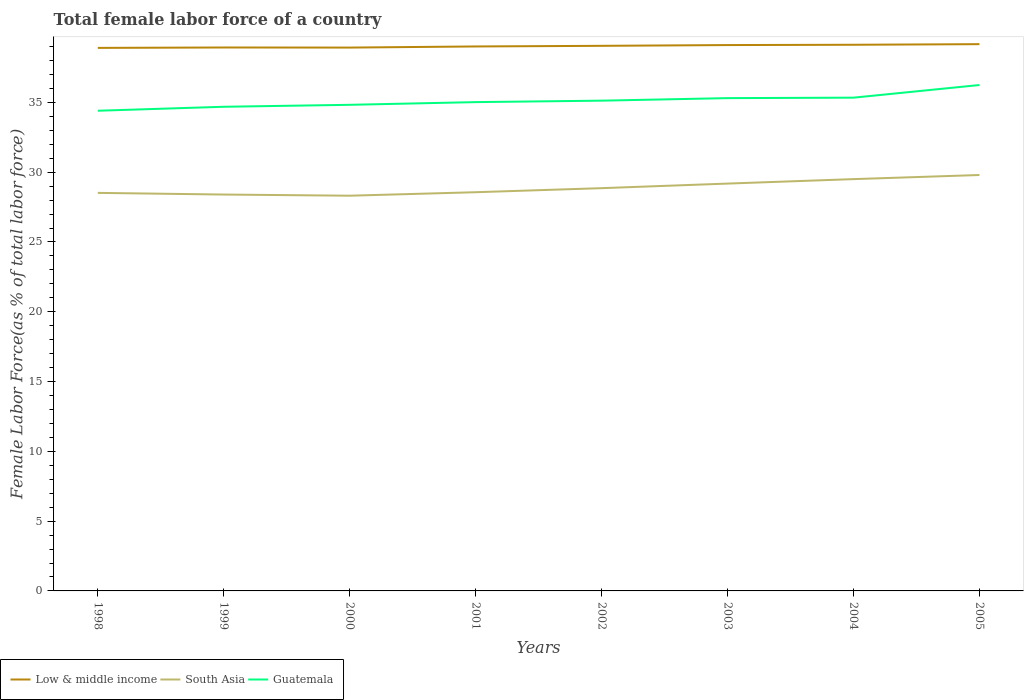How many different coloured lines are there?
Keep it short and to the point. 3. Does the line corresponding to South Asia intersect with the line corresponding to Guatemala?
Offer a very short reply. No. Across all years, what is the maximum percentage of female labor force in Guatemala?
Offer a terse response. 34.4. What is the total percentage of female labor force in South Asia in the graph?
Keep it short and to the point. -0.25. What is the difference between the highest and the second highest percentage of female labor force in Low & middle income?
Your answer should be very brief. 0.27. How many years are there in the graph?
Ensure brevity in your answer.  8. What is the difference between two consecutive major ticks on the Y-axis?
Your response must be concise. 5. How are the legend labels stacked?
Your answer should be very brief. Horizontal. What is the title of the graph?
Provide a succinct answer. Total female labor force of a country. What is the label or title of the Y-axis?
Your answer should be very brief. Female Labor Force(as % of total labor force). What is the Female Labor Force(as % of total labor force) in Low & middle income in 1998?
Give a very brief answer. 38.91. What is the Female Labor Force(as % of total labor force) in South Asia in 1998?
Provide a short and direct response. 28.52. What is the Female Labor Force(as % of total labor force) of Guatemala in 1998?
Your answer should be very brief. 34.4. What is the Female Labor Force(as % of total labor force) in Low & middle income in 1999?
Ensure brevity in your answer.  38.93. What is the Female Labor Force(as % of total labor force) in South Asia in 1999?
Offer a very short reply. 28.4. What is the Female Labor Force(as % of total labor force) in Guatemala in 1999?
Your response must be concise. 34.69. What is the Female Labor Force(as % of total labor force) in Low & middle income in 2000?
Make the answer very short. 38.93. What is the Female Labor Force(as % of total labor force) in South Asia in 2000?
Offer a terse response. 28.32. What is the Female Labor Force(as % of total labor force) of Guatemala in 2000?
Ensure brevity in your answer.  34.83. What is the Female Labor Force(as % of total labor force) of Low & middle income in 2001?
Give a very brief answer. 39.01. What is the Female Labor Force(as % of total labor force) of South Asia in 2001?
Ensure brevity in your answer.  28.57. What is the Female Labor Force(as % of total labor force) in Guatemala in 2001?
Your answer should be very brief. 35.02. What is the Female Labor Force(as % of total labor force) in Low & middle income in 2002?
Give a very brief answer. 39.05. What is the Female Labor Force(as % of total labor force) of South Asia in 2002?
Give a very brief answer. 28.86. What is the Female Labor Force(as % of total labor force) in Guatemala in 2002?
Your answer should be compact. 35.13. What is the Female Labor Force(as % of total labor force) of Low & middle income in 2003?
Your answer should be very brief. 39.11. What is the Female Labor Force(as % of total labor force) of South Asia in 2003?
Give a very brief answer. 29.18. What is the Female Labor Force(as % of total labor force) in Guatemala in 2003?
Provide a short and direct response. 35.31. What is the Female Labor Force(as % of total labor force) of Low & middle income in 2004?
Your response must be concise. 39.13. What is the Female Labor Force(as % of total labor force) of South Asia in 2004?
Provide a short and direct response. 29.5. What is the Female Labor Force(as % of total labor force) in Guatemala in 2004?
Ensure brevity in your answer.  35.34. What is the Female Labor Force(as % of total labor force) of Low & middle income in 2005?
Your answer should be compact. 39.17. What is the Female Labor Force(as % of total labor force) in South Asia in 2005?
Offer a very short reply. 29.8. What is the Female Labor Force(as % of total labor force) of Guatemala in 2005?
Make the answer very short. 36.25. Across all years, what is the maximum Female Labor Force(as % of total labor force) in Low & middle income?
Make the answer very short. 39.17. Across all years, what is the maximum Female Labor Force(as % of total labor force) in South Asia?
Your answer should be compact. 29.8. Across all years, what is the maximum Female Labor Force(as % of total labor force) in Guatemala?
Ensure brevity in your answer.  36.25. Across all years, what is the minimum Female Labor Force(as % of total labor force) in Low & middle income?
Offer a very short reply. 38.91. Across all years, what is the minimum Female Labor Force(as % of total labor force) in South Asia?
Your answer should be compact. 28.32. Across all years, what is the minimum Female Labor Force(as % of total labor force) of Guatemala?
Provide a short and direct response. 34.4. What is the total Female Labor Force(as % of total labor force) of Low & middle income in the graph?
Provide a short and direct response. 312.25. What is the total Female Labor Force(as % of total labor force) of South Asia in the graph?
Provide a short and direct response. 231.14. What is the total Female Labor Force(as % of total labor force) in Guatemala in the graph?
Your answer should be compact. 280.96. What is the difference between the Female Labor Force(as % of total labor force) of Low & middle income in 1998 and that in 1999?
Your answer should be very brief. -0.03. What is the difference between the Female Labor Force(as % of total labor force) in South Asia in 1998 and that in 1999?
Offer a very short reply. 0.12. What is the difference between the Female Labor Force(as % of total labor force) of Guatemala in 1998 and that in 1999?
Offer a very short reply. -0.28. What is the difference between the Female Labor Force(as % of total labor force) in Low & middle income in 1998 and that in 2000?
Make the answer very short. -0.02. What is the difference between the Female Labor Force(as % of total labor force) in South Asia in 1998 and that in 2000?
Provide a succinct answer. 0.2. What is the difference between the Female Labor Force(as % of total labor force) in Guatemala in 1998 and that in 2000?
Provide a short and direct response. -0.42. What is the difference between the Female Labor Force(as % of total labor force) in Low & middle income in 1998 and that in 2001?
Your response must be concise. -0.1. What is the difference between the Female Labor Force(as % of total labor force) in South Asia in 1998 and that in 2001?
Ensure brevity in your answer.  -0.05. What is the difference between the Female Labor Force(as % of total labor force) in Guatemala in 1998 and that in 2001?
Your response must be concise. -0.62. What is the difference between the Female Labor Force(as % of total labor force) in Low & middle income in 1998 and that in 2002?
Offer a very short reply. -0.15. What is the difference between the Female Labor Force(as % of total labor force) of South Asia in 1998 and that in 2002?
Offer a very short reply. -0.34. What is the difference between the Female Labor Force(as % of total labor force) in Guatemala in 1998 and that in 2002?
Your response must be concise. -0.72. What is the difference between the Female Labor Force(as % of total labor force) in Low & middle income in 1998 and that in 2003?
Your response must be concise. -0.2. What is the difference between the Female Labor Force(as % of total labor force) in South Asia in 1998 and that in 2003?
Your answer should be very brief. -0.67. What is the difference between the Female Labor Force(as % of total labor force) in Guatemala in 1998 and that in 2003?
Offer a terse response. -0.9. What is the difference between the Female Labor Force(as % of total labor force) in Low & middle income in 1998 and that in 2004?
Your answer should be very brief. -0.22. What is the difference between the Female Labor Force(as % of total labor force) of South Asia in 1998 and that in 2004?
Your answer should be very brief. -0.98. What is the difference between the Female Labor Force(as % of total labor force) of Guatemala in 1998 and that in 2004?
Make the answer very short. -0.94. What is the difference between the Female Labor Force(as % of total labor force) in Low & middle income in 1998 and that in 2005?
Offer a terse response. -0.27. What is the difference between the Female Labor Force(as % of total labor force) in South Asia in 1998 and that in 2005?
Offer a very short reply. -1.28. What is the difference between the Female Labor Force(as % of total labor force) in Guatemala in 1998 and that in 2005?
Offer a very short reply. -1.84. What is the difference between the Female Labor Force(as % of total labor force) in Low & middle income in 1999 and that in 2000?
Offer a terse response. 0.01. What is the difference between the Female Labor Force(as % of total labor force) in South Asia in 1999 and that in 2000?
Ensure brevity in your answer.  0.08. What is the difference between the Female Labor Force(as % of total labor force) of Guatemala in 1999 and that in 2000?
Ensure brevity in your answer.  -0.14. What is the difference between the Female Labor Force(as % of total labor force) of Low & middle income in 1999 and that in 2001?
Give a very brief answer. -0.07. What is the difference between the Female Labor Force(as % of total labor force) in South Asia in 1999 and that in 2001?
Offer a very short reply. -0.17. What is the difference between the Female Labor Force(as % of total labor force) of Guatemala in 1999 and that in 2001?
Your answer should be very brief. -0.33. What is the difference between the Female Labor Force(as % of total labor force) in Low & middle income in 1999 and that in 2002?
Provide a short and direct response. -0.12. What is the difference between the Female Labor Force(as % of total labor force) in South Asia in 1999 and that in 2002?
Offer a very short reply. -0.46. What is the difference between the Female Labor Force(as % of total labor force) of Guatemala in 1999 and that in 2002?
Give a very brief answer. -0.44. What is the difference between the Female Labor Force(as % of total labor force) of Low & middle income in 1999 and that in 2003?
Your answer should be very brief. -0.17. What is the difference between the Female Labor Force(as % of total labor force) in South Asia in 1999 and that in 2003?
Provide a short and direct response. -0.79. What is the difference between the Female Labor Force(as % of total labor force) of Guatemala in 1999 and that in 2003?
Give a very brief answer. -0.62. What is the difference between the Female Labor Force(as % of total labor force) of Low & middle income in 1999 and that in 2004?
Your answer should be compact. -0.2. What is the difference between the Female Labor Force(as % of total labor force) of South Asia in 1999 and that in 2004?
Ensure brevity in your answer.  -1.1. What is the difference between the Female Labor Force(as % of total labor force) in Guatemala in 1999 and that in 2004?
Provide a short and direct response. -0.65. What is the difference between the Female Labor Force(as % of total labor force) of Low & middle income in 1999 and that in 2005?
Give a very brief answer. -0.24. What is the difference between the Female Labor Force(as % of total labor force) in South Asia in 1999 and that in 2005?
Offer a very short reply. -1.4. What is the difference between the Female Labor Force(as % of total labor force) in Guatemala in 1999 and that in 2005?
Provide a short and direct response. -1.56. What is the difference between the Female Labor Force(as % of total labor force) of Low & middle income in 2000 and that in 2001?
Provide a succinct answer. -0.08. What is the difference between the Female Labor Force(as % of total labor force) of South Asia in 2000 and that in 2001?
Your answer should be very brief. -0.25. What is the difference between the Female Labor Force(as % of total labor force) in Guatemala in 2000 and that in 2001?
Your response must be concise. -0.19. What is the difference between the Female Labor Force(as % of total labor force) in Low & middle income in 2000 and that in 2002?
Offer a terse response. -0.13. What is the difference between the Female Labor Force(as % of total labor force) in South Asia in 2000 and that in 2002?
Your response must be concise. -0.54. What is the difference between the Female Labor Force(as % of total labor force) in Guatemala in 2000 and that in 2002?
Your answer should be compact. -0.3. What is the difference between the Female Labor Force(as % of total labor force) in Low & middle income in 2000 and that in 2003?
Provide a succinct answer. -0.18. What is the difference between the Female Labor Force(as % of total labor force) in South Asia in 2000 and that in 2003?
Your answer should be very brief. -0.87. What is the difference between the Female Labor Force(as % of total labor force) of Guatemala in 2000 and that in 2003?
Provide a short and direct response. -0.48. What is the difference between the Female Labor Force(as % of total labor force) in Low & middle income in 2000 and that in 2004?
Your answer should be compact. -0.2. What is the difference between the Female Labor Force(as % of total labor force) of South Asia in 2000 and that in 2004?
Your answer should be compact. -1.19. What is the difference between the Female Labor Force(as % of total labor force) of Guatemala in 2000 and that in 2004?
Offer a terse response. -0.51. What is the difference between the Female Labor Force(as % of total labor force) in Low & middle income in 2000 and that in 2005?
Make the answer very short. -0.25. What is the difference between the Female Labor Force(as % of total labor force) in South Asia in 2000 and that in 2005?
Provide a short and direct response. -1.48. What is the difference between the Female Labor Force(as % of total labor force) of Guatemala in 2000 and that in 2005?
Provide a short and direct response. -1.42. What is the difference between the Female Labor Force(as % of total labor force) of Low & middle income in 2001 and that in 2002?
Provide a succinct answer. -0.04. What is the difference between the Female Labor Force(as % of total labor force) in South Asia in 2001 and that in 2002?
Your response must be concise. -0.29. What is the difference between the Female Labor Force(as % of total labor force) in Guatemala in 2001 and that in 2002?
Offer a terse response. -0.1. What is the difference between the Female Labor Force(as % of total labor force) of Low & middle income in 2001 and that in 2003?
Give a very brief answer. -0.1. What is the difference between the Female Labor Force(as % of total labor force) of South Asia in 2001 and that in 2003?
Ensure brevity in your answer.  -0.62. What is the difference between the Female Labor Force(as % of total labor force) of Guatemala in 2001 and that in 2003?
Your answer should be compact. -0.29. What is the difference between the Female Labor Force(as % of total labor force) of Low & middle income in 2001 and that in 2004?
Your answer should be very brief. -0.12. What is the difference between the Female Labor Force(as % of total labor force) in South Asia in 2001 and that in 2004?
Make the answer very short. -0.94. What is the difference between the Female Labor Force(as % of total labor force) of Guatemala in 2001 and that in 2004?
Your response must be concise. -0.32. What is the difference between the Female Labor Force(as % of total labor force) in Low & middle income in 2001 and that in 2005?
Your response must be concise. -0.16. What is the difference between the Female Labor Force(as % of total labor force) of South Asia in 2001 and that in 2005?
Ensure brevity in your answer.  -1.23. What is the difference between the Female Labor Force(as % of total labor force) in Guatemala in 2001 and that in 2005?
Provide a short and direct response. -1.23. What is the difference between the Female Labor Force(as % of total labor force) of Low & middle income in 2002 and that in 2003?
Make the answer very short. -0.05. What is the difference between the Female Labor Force(as % of total labor force) of South Asia in 2002 and that in 2003?
Your response must be concise. -0.33. What is the difference between the Female Labor Force(as % of total labor force) of Guatemala in 2002 and that in 2003?
Offer a very short reply. -0.18. What is the difference between the Female Labor Force(as % of total labor force) in Low & middle income in 2002 and that in 2004?
Provide a succinct answer. -0.08. What is the difference between the Female Labor Force(as % of total labor force) of South Asia in 2002 and that in 2004?
Provide a short and direct response. -0.65. What is the difference between the Female Labor Force(as % of total labor force) in Guatemala in 2002 and that in 2004?
Ensure brevity in your answer.  -0.21. What is the difference between the Female Labor Force(as % of total labor force) in Low & middle income in 2002 and that in 2005?
Provide a succinct answer. -0.12. What is the difference between the Female Labor Force(as % of total labor force) in South Asia in 2002 and that in 2005?
Your answer should be compact. -0.94. What is the difference between the Female Labor Force(as % of total labor force) of Guatemala in 2002 and that in 2005?
Offer a terse response. -1.12. What is the difference between the Female Labor Force(as % of total labor force) of Low & middle income in 2003 and that in 2004?
Provide a succinct answer. -0.02. What is the difference between the Female Labor Force(as % of total labor force) in South Asia in 2003 and that in 2004?
Provide a succinct answer. -0.32. What is the difference between the Female Labor Force(as % of total labor force) of Guatemala in 2003 and that in 2004?
Your answer should be compact. -0.03. What is the difference between the Female Labor Force(as % of total labor force) in Low & middle income in 2003 and that in 2005?
Offer a terse response. -0.07. What is the difference between the Female Labor Force(as % of total labor force) of South Asia in 2003 and that in 2005?
Provide a short and direct response. -0.61. What is the difference between the Female Labor Force(as % of total labor force) of Guatemala in 2003 and that in 2005?
Your answer should be compact. -0.94. What is the difference between the Female Labor Force(as % of total labor force) of Low & middle income in 2004 and that in 2005?
Provide a short and direct response. -0.04. What is the difference between the Female Labor Force(as % of total labor force) in South Asia in 2004 and that in 2005?
Your response must be concise. -0.3. What is the difference between the Female Labor Force(as % of total labor force) in Guatemala in 2004 and that in 2005?
Your answer should be very brief. -0.91. What is the difference between the Female Labor Force(as % of total labor force) of Low & middle income in 1998 and the Female Labor Force(as % of total labor force) of South Asia in 1999?
Provide a short and direct response. 10.51. What is the difference between the Female Labor Force(as % of total labor force) of Low & middle income in 1998 and the Female Labor Force(as % of total labor force) of Guatemala in 1999?
Provide a short and direct response. 4.22. What is the difference between the Female Labor Force(as % of total labor force) of South Asia in 1998 and the Female Labor Force(as % of total labor force) of Guatemala in 1999?
Offer a very short reply. -6.17. What is the difference between the Female Labor Force(as % of total labor force) in Low & middle income in 1998 and the Female Labor Force(as % of total labor force) in South Asia in 2000?
Offer a very short reply. 10.59. What is the difference between the Female Labor Force(as % of total labor force) of Low & middle income in 1998 and the Female Labor Force(as % of total labor force) of Guatemala in 2000?
Provide a short and direct response. 4.08. What is the difference between the Female Labor Force(as % of total labor force) in South Asia in 1998 and the Female Labor Force(as % of total labor force) in Guatemala in 2000?
Provide a succinct answer. -6.31. What is the difference between the Female Labor Force(as % of total labor force) of Low & middle income in 1998 and the Female Labor Force(as % of total labor force) of South Asia in 2001?
Make the answer very short. 10.34. What is the difference between the Female Labor Force(as % of total labor force) of Low & middle income in 1998 and the Female Labor Force(as % of total labor force) of Guatemala in 2001?
Keep it short and to the point. 3.88. What is the difference between the Female Labor Force(as % of total labor force) in South Asia in 1998 and the Female Labor Force(as % of total labor force) in Guatemala in 2001?
Offer a terse response. -6.5. What is the difference between the Female Labor Force(as % of total labor force) of Low & middle income in 1998 and the Female Labor Force(as % of total labor force) of South Asia in 2002?
Offer a terse response. 10.05. What is the difference between the Female Labor Force(as % of total labor force) of Low & middle income in 1998 and the Female Labor Force(as % of total labor force) of Guatemala in 2002?
Provide a short and direct response. 3.78. What is the difference between the Female Labor Force(as % of total labor force) of South Asia in 1998 and the Female Labor Force(as % of total labor force) of Guatemala in 2002?
Provide a short and direct response. -6.61. What is the difference between the Female Labor Force(as % of total labor force) in Low & middle income in 1998 and the Female Labor Force(as % of total labor force) in South Asia in 2003?
Make the answer very short. 9.72. What is the difference between the Female Labor Force(as % of total labor force) in Low & middle income in 1998 and the Female Labor Force(as % of total labor force) in Guatemala in 2003?
Offer a terse response. 3.6. What is the difference between the Female Labor Force(as % of total labor force) of South Asia in 1998 and the Female Labor Force(as % of total labor force) of Guatemala in 2003?
Ensure brevity in your answer.  -6.79. What is the difference between the Female Labor Force(as % of total labor force) in Low & middle income in 1998 and the Female Labor Force(as % of total labor force) in South Asia in 2004?
Offer a terse response. 9.4. What is the difference between the Female Labor Force(as % of total labor force) in Low & middle income in 1998 and the Female Labor Force(as % of total labor force) in Guatemala in 2004?
Your answer should be very brief. 3.57. What is the difference between the Female Labor Force(as % of total labor force) in South Asia in 1998 and the Female Labor Force(as % of total labor force) in Guatemala in 2004?
Offer a terse response. -6.82. What is the difference between the Female Labor Force(as % of total labor force) of Low & middle income in 1998 and the Female Labor Force(as % of total labor force) of South Asia in 2005?
Offer a very short reply. 9.11. What is the difference between the Female Labor Force(as % of total labor force) in Low & middle income in 1998 and the Female Labor Force(as % of total labor force) in Guatemala in 2005?
Offer a terse response. 2.66. What is the difference between the Female Labor Force(as % of total labor force) in South Asia in 1998 and the Female Labor Force(as % of total labor force) in Guatemala in 2005?
Your response must be concise. -7.73. What is the difference between the Female Labor Force(as % of total labor force) in Low & middle income in 1999 and the Female Labor Force(as % of total labor force) in South Asia in 2000?
Offer a terse response. 10.62. What is the difference between the Female Labor Force(as % of total labor force) of Low & middle income in 1999 and the Female Labor Force(as % of total labor force) of Guatemala in 2000?
Keep it short and to the point. 4.11. What is the difference between the Female Labor Force(as % of total labor force) in South Asia in 1999 and the Female Labor Force(as % of total labor force) in Guatemala in 2000?
Offer a very short reply. -6.43. What is the difference between the Female Labor Force(as % of total labor force) in Low & middle income in 1999 and the Female Labor Force(as % of total labor force) in South Asia in 2001?
Your answer should be very brief. 10.37. What is the difference between the Female Labor Force(as % of total labor force) of Low & middle income in 1999 and the Female Labor Force(as % of total labor force) of Guatemala in 2001?
Ensure brevity in your answer.  3.91. What is the difference between the Female Labor Force(as % of total labor force) in South Asia in 1999 and the Female Labor Force(as % of total labor force) in Guatemala in 2001?
Provide a succinct answer. -6.62. What is the difference between the Female Labor Force(as % of total labor force) in Low & middle income in 1999 and the Female Labor Force(as % of total labor force) in South Asia in 2002?
Provide a short and direct response. 10.08. What is the difference between the Female Labor Force(as % of total labor force) of Low & middle income in 1999 and the Female Labor Force(as % of total labor force) of Guatemala in 2002?
Offer a terse response. 3.81. What is the difference between the Female Labor Force(as % of total labor force) of South Asia in 1999 and the Female Labor Force(as % of total labor force) of Guatemala in 2002?
Offer a terse response. -6.73. What is the difference between the Female Labor Force(as % of total labor force) of Low & middle income in 1999 and the Female Labor Force(as % of total labor force) of South Asia in 2003?
Your answer should be very brief. 9.75. What is the difference between the Female Labor Force(as % of total labor force) of Low & middle income in 1999 and the Female Labor Force(as % of total labor force) of Guatemala in 2003?
Offer a terse response. 3.63. What is the difference between the Female Labor Force(as % of total labor force) of South Asia in 1999 and the Female Labor Force(as % of total labor force) of Guatemala in 2003?
Keep it short and to the point. -6.91. What is the difference between the Female Labor Force(as % of total labor force) of Low & middle income in 1999 and the Female Labor Force(as % of total labor force) of South Asia in 2004?
Your answer should be very brief. 9.43. What is the difference between the Female Labor Force(as % of total labor force) of Low & middle income in 1999 and the Female Labor Force(as % of total labor force) of Guatemala in 2004?
Keep it short and to the point. 3.59. What is the difference between the Female Labor Force(as % of total labor force) of South Asia in 1999 and the Female Labor Force(as % of total labor force) of Guatemala in 2004?
Make the answer very short. -6.94. What is the difference between the Female Labor Force(as % of total labor force) of Low & middle income in 1999 and the Female Labor Force(as % of total labor force) of South Asia in 2005?
Keep it short and to the point. 9.14. What is the difference between the Female Labor Force(as % of total labor force) of Low & middle income in 1999 and the Female Labor Force(as % of total labor force) of Guatemala in 2005?
Your response must be concise. 2.69. What is the difference between the Female Labor Force(as % of total labor force) in South Asia in 1999 and the Female Labor Force(as % of total labor force) in Guatemala in 2005?
Your answer should be very brief. -7.85. What is the difference between the Female Labor Force(as % of total labor force) in Low & middle income in 2000 and the Female Labor Force(as % of total labor force) in South Asia in 2001?
Make the answer very short. 10.36. What is the difference between the Female Labor Force(as % of total labor force) in Low & middle income in 2000 and the Female Labor Force(as % of total labor force) in Guatemala in 2001?
Provide a short and direct response. 3.91. What is the difference between the Female Labor Force(as % of total labor force) of South Asia in 2000 and the Female Labor Force(as % of total labor force) of Guatemala in 2001?
Keep it short and to the point. -6.71. What is the difference between the Female Labor Force(as % of total labor force) of Low & middle income in 2000 and the Female Labor Force(as % of total labor force) of South Asia in 2002?
Your answer should be very brief. 10.07. What is the difference between the Female Labor Force(as % of total labor force) in Low & middle income in 2000 and the Female Labor Force(as % of total labor force) in Guatemala in 2002?
Offer a terse response. 3.8. What is the difference between the Female Labor Force(as % of total labor force) of South Asia in 2000 and the Female Labor Force(as % of total labor force) of Guatemala in 2002?
Offer a terse response. -6.81. What is the difference between the Female Labor Force(as % of total labor force) in Low & middle income in 2000 and the Female Labor Force(as % of total labor force) in South Asia in 2003?
Provide a succinct answer. 9.74. What is the difference between the Female Labor Force(as % of total labor force) in Low & middle income in 2000 and the Female Labor Force(as % of total labor force) in Guatemala in 2003?
Provide a short and direct response. 3.62. What is the difference between the Female Labor Force(as % of total labor force) in South Asia in 2000 and the Female Labor Force(as % of total labor force) in Guatemala in 2003?
Keep it short and to the point. -6.99. What is the difference between the Female Labor Force(as % of total labor force) of Low & middle income in 2000 and the Female Labor Force(as % of total labor force) of South Asia in 2004?
Provide a short and direct response. 9.43. What is the difference between the Female Labor Force(as % of total labor force) of Low & middle income in 2000 and the Female Labor Force(as % of total labor force) of Guatemala in 2004?
Offer a very short reply. 3.59. What is the difference between the Female Labor Force(as % of total labor force) of South Asia in 2000 and the Female Labor Force(as % of total labor force) of Guatemala in 2004?
Give a very brief answer. -7.02. What is the difference between the Female Labor Force(as % of total labor force) of Low & middle income in 2000 and the Female Labor Force(as % of total labor force) of South Asia in 2005?
Offer a terse response. 9.13. What is the difference between the Female Labor Force(as % of total labor force) in Low & middle income in 2000 and the Female Labor Force(as % of total labor force) in Guatemala in 2005?
Your answer should be compact. 2.68. What is the difference between the Female Labor Force(as % of total labor force) in South Asia in 2000 and the Female Labor Force(as % of total labor force) in Guatemala in 2005?
Keep it short and to the point. -7.93. What is the difference between the Female Labor Force(as % of total labor force) of Low & middle income in 2001 and the Female Labor Force(as % of total labor force) of South Asia in 2002?
Your answer should be compact. 10.15. What is the difference between the Female Labor Force(as % of total labor force) of Low & middle income in 2001 and the Female Labor Force(as % of total labor force) of Guatemala in 2002?
Provide a short and direct response. 3.88. What is the difference between the Female Labor Force(as % of total labor force) in South Asia in 2001 and the Female Labor Force(as % of total labor force) in Guatemala in 2002?
Provide a succinct answer. -6.56. What is the difference between the Female Labor Force(as % of total labor force) in Low & middle income in 2001 and the Female Labor Force(as % of total labor force) in South Asia in 2003?
Offer a terse response. 9.82. What is the difference between the Female Labor Force(as % of total labor force) in Low & middle income in 2001 and the Female Labor Force(as % of total labor force) in Guatemala in 2003?
Your answer should be compact. 3.7. What is the difference between the Female Labor Force(as % of total labor force) in South Asia in 2001 and the Female Labor Force(as % of total labor force) in Guatemala in 2003?
Your response must be concise. -6.74. What is the difference between the Female Labor Force(as % of total labor force) in Low & middle income in 2001 and the Female Labor Force(as % of total labor force) in South Asia in 2004?
Offer a very short reply. 9.51. What is the difference between the Female Labor Force(as % of total labor force) of Low & middle income in 2001 and the Female Labor Force(as % of total labor force) of Guatemala in 2004?
Offer a very short reply. 3.67. What is the difference between the Female Labor Force(as % of total labor force) of South Asia in 2001 and the Female Labor Force(as % of total labor force) of Guatemala in 2004?
Your answer should be compact. -6.78. What is the difference between the Female Labor Force(as % of total labor force) in Low & middle income in 2001 and the Female Labor Force(as % of total labor force) in South Asia in 2005?
Make the answer very short. 9.21. What is the difference between the Female Labor Force(as % of total labor force) of Low & middle income in 2001 and the Female Labor Force(as % of total labor force) of Guatemala in 2005?
Your answer should be very brief. 2.76. What is the difference between the Female Labor Force(as % of total labor force) in South Asia in 2001 and the Female Labor Force(as % of total labor force) in Guatemala in 2005?
Ensure brevity in your answer.  -7.68. What is the difference between the Female Labor Force(as % of total labor force) of Low & middle income in 2002 and the Female Labor Force(as % of total labor force) of South Asia in 2003?
Provide a short and direct response. 9.87. What is the difference between the Female Labor Force(as % of total labor force) of Low & middle income in 2002 and the Female Labor Force(as % of total labor force) of Guatemala in 2003?
Provide a short and direct response. 3.75. What is the difference between the Female Labor Force(as % of total labor force) of South Asia in 2002 and the Female Labor Force(as % of total labor force) of Guatemala in 2003?
Keep it short and to the point. -6.45. What is the difference between the Female Labor Force(as % of total labor force) of Low & middle income in 2002 and the Female Labor Force(as % of total labor force) of South Asia in 2004?
Keep it short and to the point. 9.55. What is the difference between the Female Labor Force(as % of total labor force) in Low & middle income in 2002 and the Female Labor Force(as % of total labor force) in Guatemala in 2004?
Your response must be concise. 3.71. What is the difference between the Female Labor Force(as % of total labor force) of South Asia in 2002 and the Female Labor Force(as % of total labor force) of Guatemala in 2004?
Ensure brevity in your answer.  -6.48. What is the difference between the Female Labor Force(as % of total labor force) of Low & middle income in 2002 and the Female Labor Force(as % of total labor force) of South Asia in 2005?
Keep it short and to the point. 9.26. What is the difference between the Female Labor Force(as % of total labor force) in Low & middle income in 2002 and the Female Labor Force(as % of total labor force) in Guatemala in 2005?
Make the answer very short. 2.81. What is the difference between the Female Labor Force(as % of total labor force) in South Asia in 2002 and the Female Labor Force(as % of total labor force) in Guatemala in 2005?
Make the answer very short. -7.39. What is the difference between the Female Labor Force(as % of total labor force) of Low & middle income in 2003 and the Female Labor Force(as % of total labor force) of South Asia in 2004?
Provide a short and direct response. 9.61. What is the difference between the Female Labor Force(as % of total labor force) in Low & middle income in 2003 and the Female Labor Force(as % of total labor force) in Guatemala in 2004?
Ensure brevity in your answer.  3.77. What is the difference between the Female Labor Force(as % of total labor force) in South Asia in 2003 and the Female Labor Force(as % of total labor force) in Guatemala in 2004?
Provide a short and direct response. -6.16. What is the difference between the Female Labor Force(as % of total labor force) in Low & middle income in 2003 and the Female Labor Force(as % of total labor force) in South Asia in 2005?
Provide a succinct answer. 9.31. What is the difference between the Female Labor Force(as % of total labor force) of Low & middle income in 2003 and the Female Labor Force(as % of total labor force) of Guatemala in 2005?
Your response must be concise. 2.86. What is the difference between the Female Labor Force(as % of total labor force) of South Asia in 2003 and the Female Labor Force(as % of total labor force) of Guatemala in 2005?
Provide a short and direct response. -7.06. What is the difference between the Female Labor Force(as % of total labor force) in Low & middle income in 2004 and the Female Labor Force(as % of total labor force) in South Asia in 2005?
Ensure brevity in your answer.  9.33. What is the difference between the Female Labor Force(as % of total labor force) in Low & middle income in 2004 and the Female Labor Force(as % of total labor force) in Guatemala in 2005?
Provide a short and direct response. 2.88. What is the difference between the Female Labor Force(as % of total labor force) of South Asia in 2004 and the Female Labor Force(as % of total labor force) of Guatemala in 2005?
Provide a short and direct response. -6.74. What is the average Female Labor Force(as % of total labor force) of Low & middle income per year?
Ensure brevity in your answer.  39.03. What is the average Female Labor Force(as % of total labor force) in South Asia per year?
Give a very brief answer. 28.89. What is the average Female Labor Force(as % of total labor force) in Guatemala per year?
Your answer should be compact. 35.12. In the year 1998, what is the difference between the Female Labor Force(as % of total labor force) in Low & middle income and Female Labor Force(as % of total labor force) in South Asia?
Provide a succinct answer. 10.39. In the year 1998, what is the difference between the Female Labor Force(as % of total labor force) of Low & middle income and Female Labor Force(as % of total labor force) of Guatemala?
Keep it short and to the point. 4.5. In the year 1998, what is the difference between the Female Labor Force(as % of total labor force) in South Asia and Female Labor Force(as % of total labor force) in Guatemala?
Provide a short and direct response. -5.88. In the year 1999, what is the difference between the Female Labor Force(as % of total labor force) in Low & middle income and Female Labor Force(as % of total labor force) in South Asia?
Give a very brief answer. 10.54. In the year 1999, what is the difference between the Female Labor Force(as % of total labor force) in Low & middle income and Female Labor Force(as % of total labor force) in Guatemala?
Ensure brevity in your answer.  4.25. In the year 1999, what is the difference between the Female Labor Force(as % of total labor force) in South Asia and Female Labor Force(as % of total labor force) in Guatemala?
Your answer should be very brief. -6.29. In the year 2000, what is the difference between the Female Labor Force(as % of total labor force) of Low & middle income and Female Labor Force(as % of total labor force) of South Asia?
Provide a succinct answer. 10.61. In the year 2000, what is the difference between the Female Labor Force(as % of total labor force) of Low & middle income and Female Labor Force(as % of total labor force) of Guatemala?
Provide a short and direct response. 4.1. In the year 2000, what is the difference between the Female Labor Force(as % of total labor force) in South Asia and Female Labor Force(as % of total labor force) in Guatemala?
Provide a short and direct response. -6.51. In the year 2001, what is the difference between the Female Labor Force(as % of total labor force) of Low & middle income and Female Labor Force(as % of total labor force) of South Asia?
Keep it short and to the point. 10.44. In the year 2001, what is the difference between the Female Labor Force(as % of total labor force) of Low & middle income and Female Labor Force(as % of total labor force) of Guatemala?
Your answer should be compact. 3.99. In the year 2001, what is the difference between the Female Labor Force(as % of total labor force) in South Asia and Female Labor Force(as % of total labor force) in Guatemala?
Offer a very short reply. -6.46. In the year 2002, what is the difference between the Female Labor Force(as % of total labor force) in Low & middle income and Female Labor Force(as % of total labor force) in South Asia?
Provide a succinct answer. 10.2. In the year 2002, what is the difference between the Female Labor Force(as % of total labor force) in Low & middle income and Female Labor Force(as % of total labor force) in Guatemala?
Offer a terse response. 3.93. In the year 2002, what is the difference between the Female Labor Force(as % of total labor force) in South Asia and Female Labor Force(as % of total labor force) in Guatemala?
Provide a succinct answer. -6.27. In the year 2003, what is the difference between the Female Labor Force(as % of total labor force) of Low & middle income and Female Labor Force(as % of total labor force) of South Asia?
Your response must be concise. 9.92. In the year 2003, what is the difference between the Female Labor Force(as % of total labor force) in Low & middle income and Female Labor Force(as % of total labor force) in Guatemala?
Your answer should be compact. 3.8. In the year 2003, what is the difference between the Female Labor Force(as % of total labor force) in South Asia and Female Labor Force(as % of total labor force) in Guatemala?
Provide a short and direct response. -6.12. In the year 2004, what is the difference between the Female Labor Force(as % of total labor force) in Low & middle income and Female Labor Force(as % of total labor force) in South Asia?
Your answer should be very brief. 9.63. In the year 2004, what is the difference between the Female Labor Force(as % of total labor force) in Low & middle income and Female Labor Force(as % of total labor force) in Guatemala?
Make the answer very short. 3.79. In the year 2004, what is the difference between the Female Labor Force(as % of total labor force) of South Asia and Female Labor Force(as % of total labor force) of Guatemala?
Make the answer very short. -5.84. In the year 2005, what is the difference between the Female Labor Force(as % of total labor force) in Low & middle income and Female Labor Force(as % of total labor force) in South Asia?
Your response must be concise. 9.38. In the year 2005, what is the difference between the Female Labor Force(as % of total labor force) in Low & middle income and Female Labor Force(as % of total labor force) in Guatemala?
Your response must be concise. 2.93. In the year 2005, what is the difference between the Female Labor Force(as % of total labor force) of South Asia and Female Labor Force(as % of total labor force) of Guatemala?
Your answer should be compact. -6.45. What is the ratio of the Female Labor Force(as % of total labor force) of South Asia in 1998 to that in 1999?
Provide a short and direct response. 1. What is the ratio of the Female Labor Force(as % of total labor force) in Guatemala in 1998 to that in 1999?
Make the answer very short. 0.99. What is the ratio of the Female Labor Force(as % of total labor force) in Guatemala in 1998 to that in 2001?
Make the answer very short. 0.98. What is the ratio of the Female Labor Force(as % of total labor force) in South Asia in 1998 to that in 2002?
Provide a succinct answer. 0.99. What is the ratio of the Female Labor Force(as % of total labor force) of Guatemala in 1998 to that in 2002?
Make the answer very short. 0.98. What is the ratio of the Female Labor Force(as % of total labor force) of Low & middle income in 1998 to that in 2003?
Your answer should be very brief. 0.99. What is the ratio of the Female Labor Force(as % of total labor force) in South Asia in 1998 to that in 2003?
Give a very brief answer. 0.98. What is the ratio of the Female Labor Force(as % of total labor force) of Guatemala in 1998 to that in 2003?
Give a very brief answer. 0.97. What is the ratio of the Female Labor Force(as % of total labor force) in Low & middle income in 1998 to that in 2004?
Provide a succinct answer. 0.99. What is the ratio of the Female Labor Force(as % of total labor force) of South Asia in 1998 to that in 2004?
Ensure brevity in your answer.  0.97. What is the ratio of the Female Labor Force(as % of total labor force) in Guatemala in 1998 to that in 2004?
Provide a short and direct response. 0.97. What is the ratio of the Female Labor Force(as % of total labor force) in South Asia in 1998 to that in 2005?
Your answer should be compact. 0.96. What is the ratio of the Female Labor Force(as % of total labor force) in Guatemala in 1998 to that in 2005?
Your response must be concise. 0.95. What is the ratio of the Female Labor Force(as % of total labor force) in Low & middle income in 1999 to that in 2000?
Provide a succinct answer. 1. What is the ratio of the Female Labor Force(as % of total labor force) in South Asia in 1999 to that in 2000?
Your response must be concise. 1. What is the ratio of the Female Labor Force(as % of total labor force) in Guatemala in 1999 to that in 2000?
Your response must be concise. 1. What is the ratio of the Female Labor Force(as % of total labor force) of Low & middle income in 1999 to that in 2002?
Give a very brief answer. 1. What is the ratio of the Female Labor Force(as % of total labor force) in South Asia in 1999 to that in 2002?
Provide a succinct answer. 0.98. What is the ratio of the Female Labor Force(as % of total labor force) of Guatemala in 1999 to that in 2002?
Ensure brevity in your answer.  0.99. What is the ratio of the Female Labor Force(as % of total labor force) in South Asia in 1999 to that in 2003?
Give a very brief answer. 0.97. What is the ratio of the Female Labor Force(as % of total labor force) of Guatemala in 1999 to that in 2003?
Make the answer very short. 0.98. What is the ratio of the Female Labor Force(as % of total labor force) of Low & middle income in 1999 to that in 2004?
Provide a short and direct response. 0.99. What is the ratio of the Female Labor Force(as % of total labor force) in South Asia in 1999 to that in 2004?
Your answer should be compact. 0.96. What is the ratio of the Female Labor Force(as % of total labor force) in Guatemala in 1999 to that in 2004?
Provide a succinct answer. 0.98. What is the ratio of the Female Labor Force(as % of total labor force) in South Asia in 1999 to that in 2005?
Give a very brief answer. 0.95. What is the ratio of the Female Labor Force(as % of total labor force) in Low & middle income in 2000 to that in 2001?
Ensure brevity in your answer.  1. What is the ratio of the Female Labor Force(as % of total labor force) in South Asia in 2000 to that in 2001?
Give a very brief answer. 0.99. What is the ratio of the Female Labor Force(as % of total labor force) in Low & middle income in 2000 to that in 2002?
Keep it short and to the point. 1. What is the ratio of the Female Labor Force(as % of total labor force) of South Asia in 2000 to that in 2002?
Provide a succinct answer. 0.98. What is the ratio of the Female Labor Force(as % of total labor force) in Guatemala in 2000 to that in 2002?
Provide a succinct answer. 0.99. What is the ratio of the Female Labor Force(as % of total labor force) in Low & middle income in 2000 to that in 2003?
Ensure brevity in your answer.  1. What is the ratio of the Female Labor Force(as % of total labor force) of South Asia in 2000 to that in 2003?
Offer a terse response. 0.97. What is the ratio of the Female Labor Force(as % of total labor force) in Guatemala in 2000 to that in 2003?
Give a very brief answer. 0.99. What is the ratio of the Female Labor Force(as % of total labor force) of Low & middle income in 2000 to that in 2004?
Your answer should be very brief. 0.99. What is the ratio of the Female Labor Force(as % of total labor force) of South Asia in 2000 to that in 2004?
Your answer should be very brief. 0.96. What is the ratio of the Female Labor Force(as % of total labor force) in Guatemala in 2000 to that in 2004?
Make the answer very short. 0.99. What is the ratio of the Female Labor Force(as % of total labor force) of South Asia in 2000 to that in 2005?
Your answer should be very brief. 0.95. What is the ratio of the Female Labor Force(as % of total labor force) in Guatemala in 2000 to that in 2005?
Ensure brevity in your answer.  0.96. What is the ratio of the Female Labor Force(as % of total labor force) in Low & middle income in 2001 to that in 2002?
Ensure brevity in your answer.  1. What is the ratio of the Female Labor Force(as % of total labor force) in South Asia in 2001 to that in 2003?
Your answer should be compact. 0.98. What is the ratio of the Female Labor Force(as % of total labor force) in Guatemala in 2001 to that in 2003?
Keep it short and to the point. 0.99. What is the ratio of the Female Labor Force(as % of total labor force) of Low & middle income in 2001 to that in 2004?
Offer a very short reply. 1. What is the ratio of the Female Labor Force(as % of total labor force) of South Asia in 2001 to that in 2004?
Your response must be concise. 0.97. What is the ratio of the Female Labor Force(as % of total labor force) in South Asia in 2001 to that in 2005?
Provide a succinct answer. 0.96. What is the ratio of the Female Labor Force(as % of total labor force) in Guatemala in 2001 to that in 2005?
Ensure brevity in your answer.  0.97. What is the ratio of the Female Labor Force(as % of total labor force) in Low & middle income in 2002 to that in 2003?
Provide a succinct answer. 1. What is the ratio of the Female Labor Force(as % of total labor force) in Guatemala in 2002 to that in 2003?
Keep it short and to the point. 0.99. What is the ratio of the Female Labor Force(as % of total labor force) of South Asia in 2002 to that in 2004?
Your answer should be compact. 0.98. What is the ratio of the Female Labor Force(as % of total labor force) of Guatemala in 2002 to that in 2004?
Ensure brevity in your answer.  0.99. What is the ratio of the Female Labor Force(as % of total labor force) in Low & middle income in 2002 to that in 2005?
Keep it short and to the point. 1. What is the ratio of the Female Labor Force(as % of total labor force) of South Asia in 2002 to that in 2005?
Ensure brevity in your answer.  0.97. What is the ratio of the Female Labor Force(as % of total labor force) in Guatemala in 2002 to that in 2005?
Provide a succinct answer. 0.97. What is the ratio of the Female Labor Force(as % of total labor force) of Low & middle income in 2003 to that in 2004?
Provide a short and direct response. 1. What is the ratio of the Female Labor Force(as % of total labor force) in South Asia in 2003 to that in 2004?
Offer a terse response. 0.99. What is the ratio of the Female Labor Force(as % of total labor force) of Low & middle income in 2003 to that in 2005?
Offer a terse response. 1. What is the ratio of the Female Labor Force(as % of total labor force) in South Asia in 2003 to that in 2005?
Your response must be concise. 0.98. What is the ratio of the Female Labor Force(as % of total labor force) of Guatemala in 2003 to that in 2005?
Ensure brevity in your answer.  0.97. What is the ratio of the Female Labor Force(as % of total labor force) of Low & middle income in 2004 to that in 2005?
Your response must be concise. 1. What is the ratio of the Female Labor Force(as % of total labor force) in Guatemala in 2004 to that in 2005?
Your answer should be compact. 0.97. What is the difference between the highest and the second highest Female Labor Force(as % of total labor force) of Low & middle income?
Keep it short and to the point. 0.04. What is the difference between the highest and the second highest Female Labor Force(as % of total labor force) of South Asia?
Provide a short and direct response. 0.3. What is the difference between the highest and the second highest Female Labor Force(as % of total labor force) in Guatemala?
Keep it short and to the point. 0.91. What is the difference between the highest and the lowest Female Labor Force(as % of total labor force) of Low & middle income?
Your answer should be compact. 0.27. What is the difference between the highest and the lowest Female Labor Force(as % of total labor force) of South Asia?
Provide a short and direct response. 1.48. What is the difference between the highest and the lowest Female Labor Force(as % of total labor force) in Guatemala?
Ensure brevity in your answer.  1.84. 